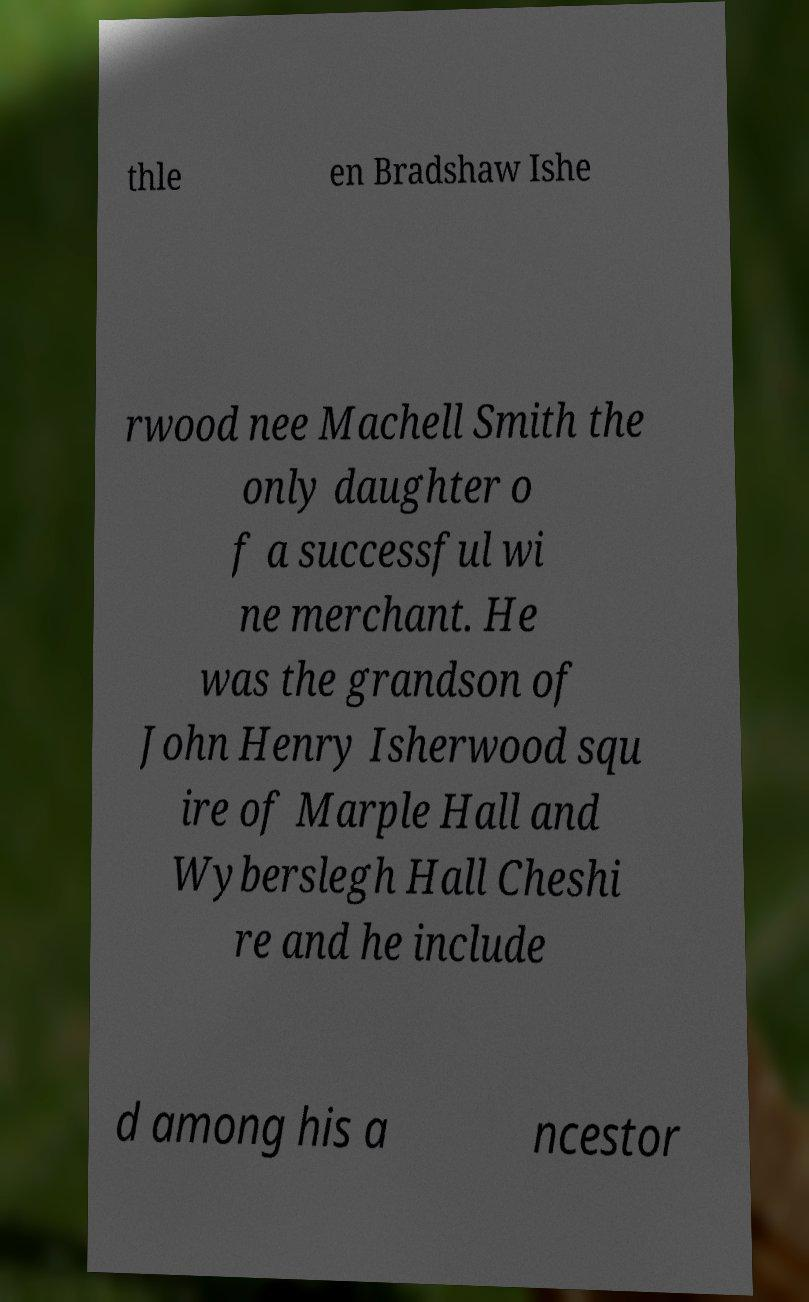What messages or text are displayed in this image? I need them in a readable, typed format. thle en Bradshaw Ishe rwood nee Machell Smith the only daughter o f a successful wi ne merchant. He was the grandson of John Henry Isherwood squ ire of Marple Hall and Wyberslegh Hall Cheshi re and he include d among his a ncestor 